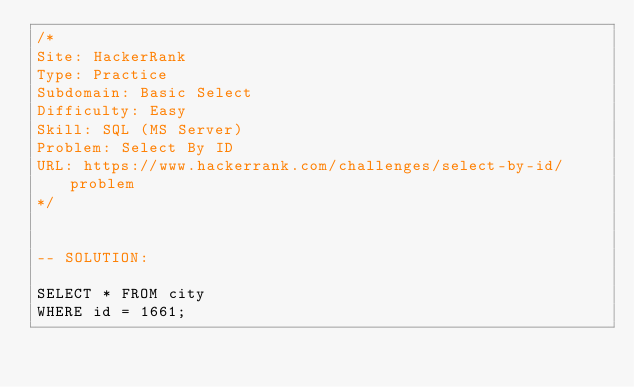Convert code to text. <code><loc_0><loc_0><loc_500><loc_500><_SQL_>/*
Site: HackerRank
Type: Practice
Subdomain: Basic Select
Difficulty: Easy
Skill: SQL (MS Server)
Problem: Select By ID
URL: https://www.hackerrank.com/challenges/select-by-id/problem
*/


-- SOLUTION:

SELECT * FROM city
WHERE id = 1661;</code> 